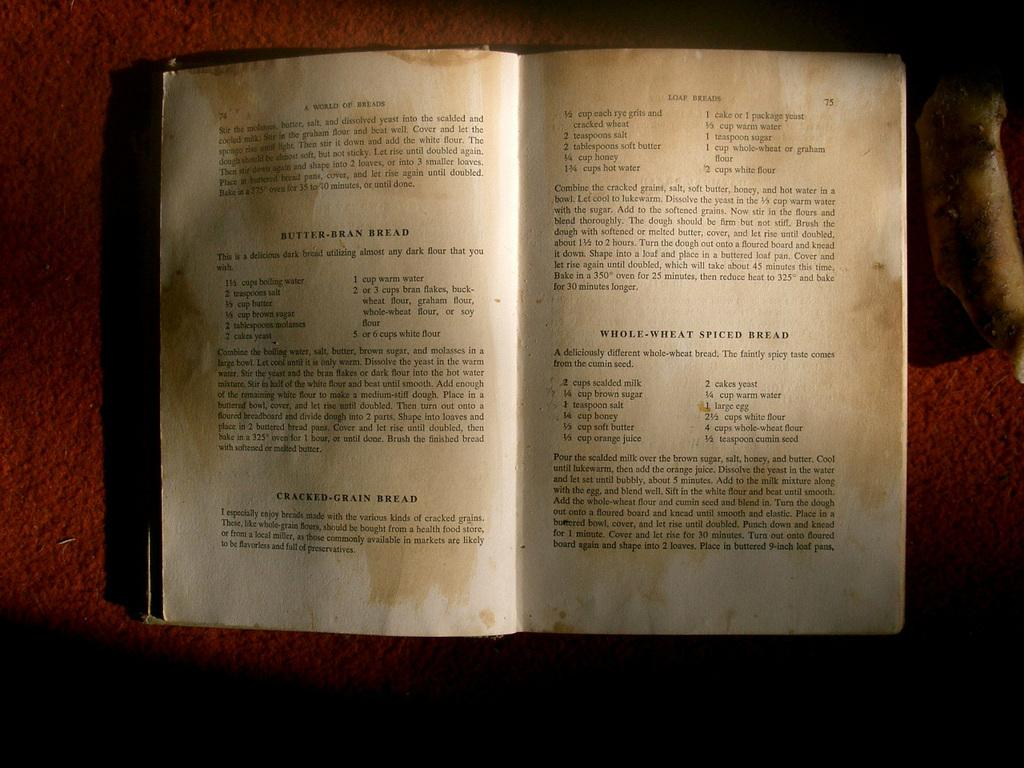<image>
Describe the image concisely. An old recipe book opened to pages on butter bran bread and whole wheat spiced bread. 